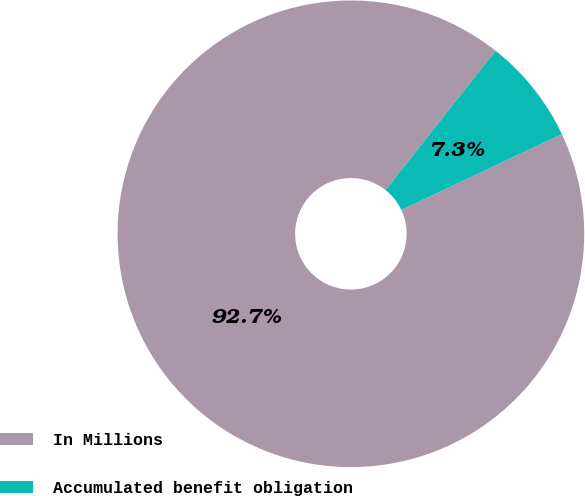<chart> <loc_0><loc_0><loc_500><loc_500><pie_chart><fcel>In Millions<fcel>Accumulated benefit obligation<nl><fcel>92.68%<fcel>7.32%<nl></chart> 